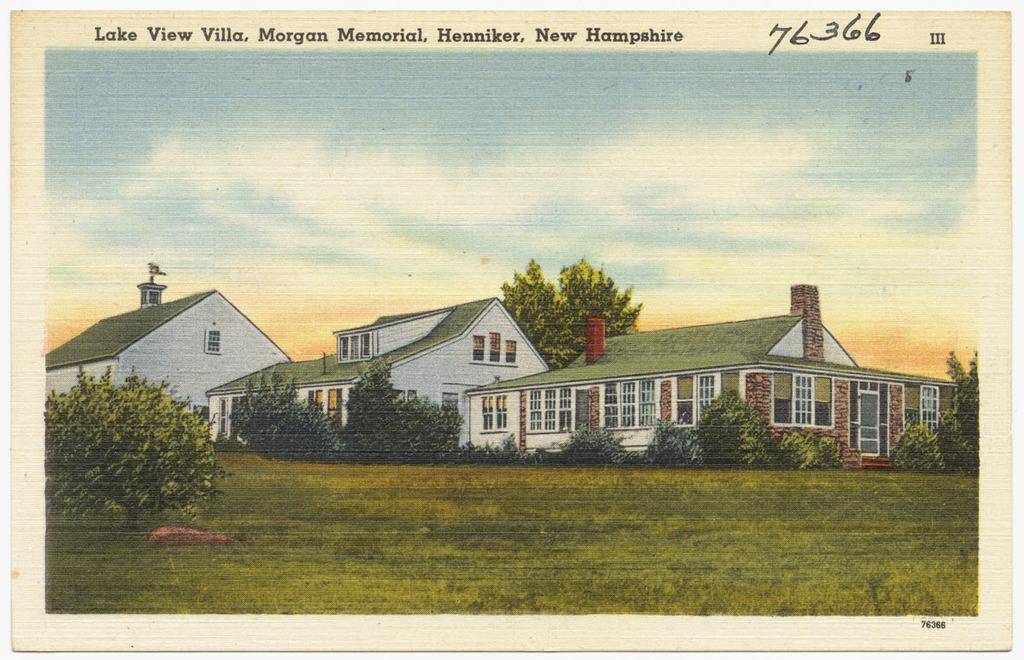Provide a one-sentence caption for the provided image. A postcard from Lake View Villa, New Hampshire has a drawing of a house on the front of it. 